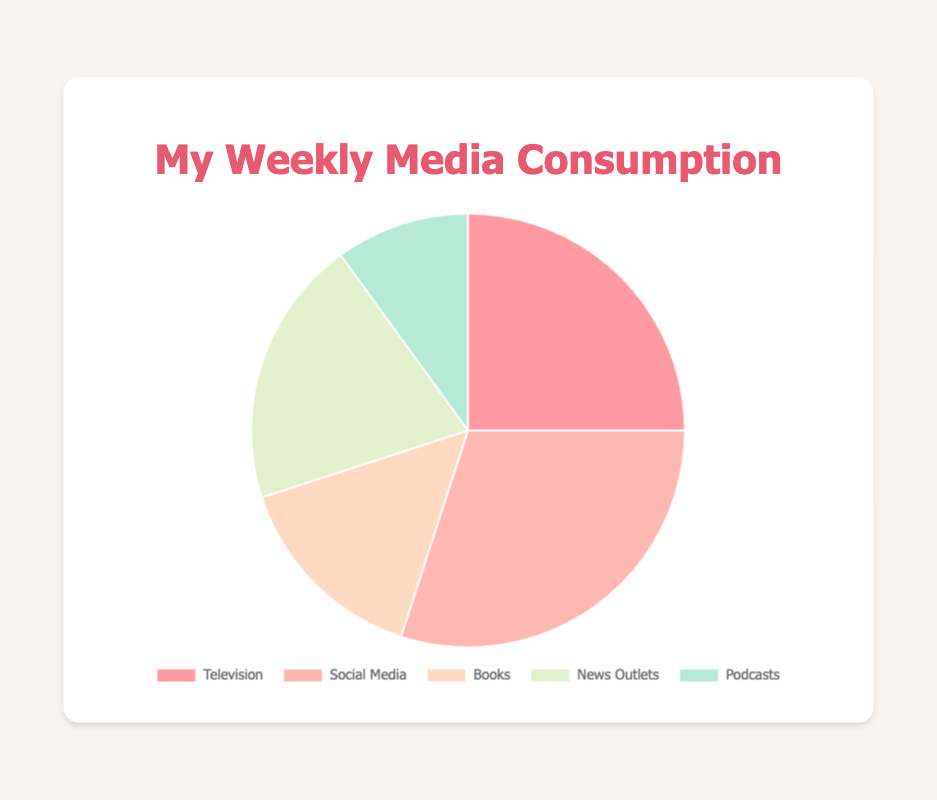What is the percentage of weekly media consumption for Social Media? The chart shows that Social Media accounts for 30% of weekly media consumption.
Answer: 30% Which type of media is consumed the least weekly? According to the chart, Podcasts have the smallest section, indicating they are consumed the least.
Answer: Podcasts How much greater is the percentage of weekly consumption of Social Media compared to Books? Social Media consumption is 30%, and Books consumption is 15%. The difference is 30% - 15% = 15%.
Answer: 15% Among the media types, which one has a 25% consumption rate? From the chart, it is clear that Television has a 25% consumption rate.
Answer: Television What is the combined percentage of weekly consumption for Television and News Outlets? The percentage for Television is 25%, and for News Outlets is 20%. Therefore, the combined percentage is 25% + 20% = 45%.
Answer: 45% Which media type uses the color red in the pie chart? Based on the chart, the section colored red corresponds to Television.
Answer: Television Is the percentage of time spent on Social Media greater than the combined percentage of Books and Podcasts? Social Media has a 30% consumption rate. Books (15%) and Podcasts (10%) combined add up to 25%. 30% is greater than 25%.
Answer: Yes Which media types together make up 35% of weekly consumption? News Outlets (20%) and Podcasts (10%) together sum to 30%, while Books (15%) and Podcasts (10%) sum to 25%. Therefore, Television (25%) and Podcasts (10%) together make up 35%.
Answer: Television and Podcasts 